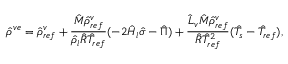<formula> <loc_0><loc_0><loc_500><loc_500>\hat { \rho } ^ { v e } = \hat { \rho } _ { r e f } ^ { v } + \frac { \hat { M } \hat { \rho } _ { r e f } ^ { v } } { \hat { \rho } _ { l } \hat { R } \hat { T } _ { r e f } } ( - 2 \hat { H } _ { l } \hat { \sigma } - \hat { \Pi } ) + \frac { \hat { L } _ { v } \hat { M } \hat { \rho } _ { r e f } ^ { v } } { \hat { R } \hat { T } _ { r e f } ^ { 2 } } ( \hat { T } _ { s } - \hat { T } _ { r e f } ) ,</formula> 